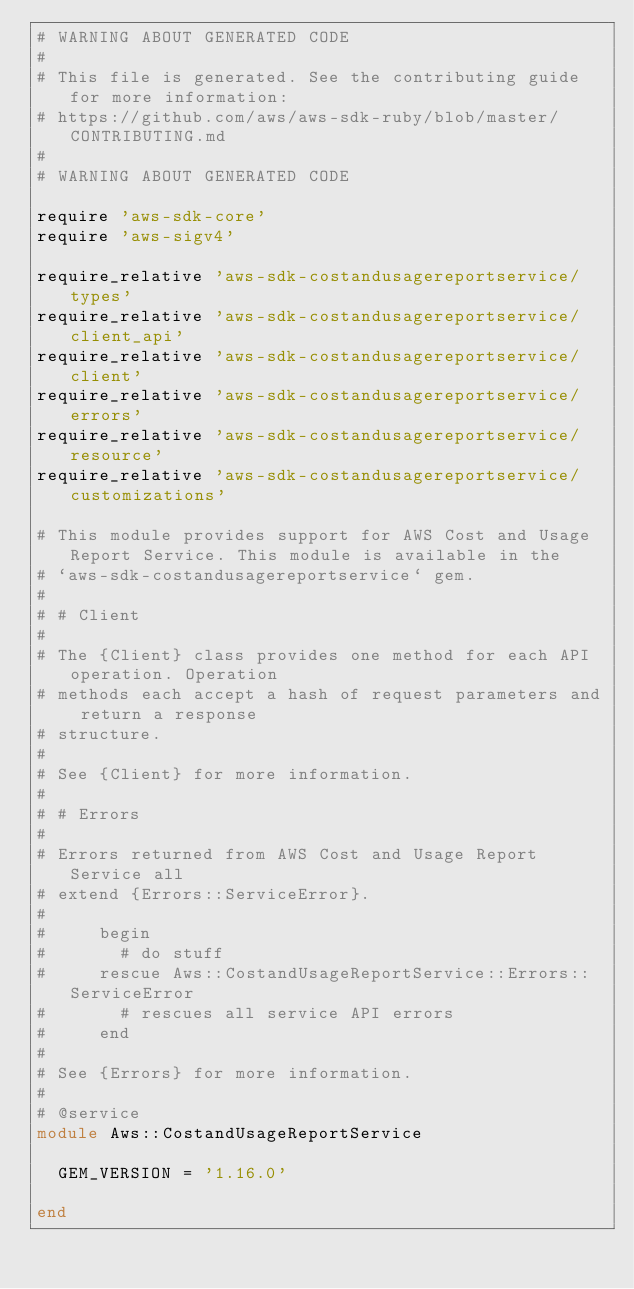Convert code to text. <code><loc_0><loc_0><loc_500><loc_500><_Ruby_># WARNING ABOUT GENERATED CODE
#
# This file is generated. See the contributing guide for more information:
# https://github.com/aws/aws-sdk-ruby/blob/master/CONTRIBUTING.md
#
# WARNING ABOUT GENERATED CODE

require 'aws-sdk-core'
require 'aws-sigv4'

require_relative 'aws-sdk-costandusagereportservice/types'
require_relative 'aws-sdk-costandusagereportservice/client_api'
require_relative 'aws-sdk-costandusagereportservice/client'
require_relative 'aws-sdk-costandusagereportservice/errors'
require_relative 'aws-sdk-costandusagereportservice/resource'
require_relative 'aws-sdk-costandusagereportservice/customizations'

# This module provides support for AWS Cost and Usage Report Service. This module is available in the
# `aws-sdk-costandusagereportservice` gem.
#
# # Client
#
# The {Client} class provides one method for each API operation. Operation
# methods each accept a hash of request parameters and return a response
# structure.
#
# See {Client} for more information.
#
# # Errors
#
# Errors returned from AWS Cost and Usage Report Service all
# extend {Errors::ServiceError}.
#
#     begin
#       # do stuff
#     rescue Aws::CostandUsageReportService::Errors::ServiceError
#       # rescues all service API errors
#     end
#
# See {Errors} for more information.
#
# @service
module Aws::CostandUsageReportService

  GEM_VERSION = '1.16.0'

end
</code> 